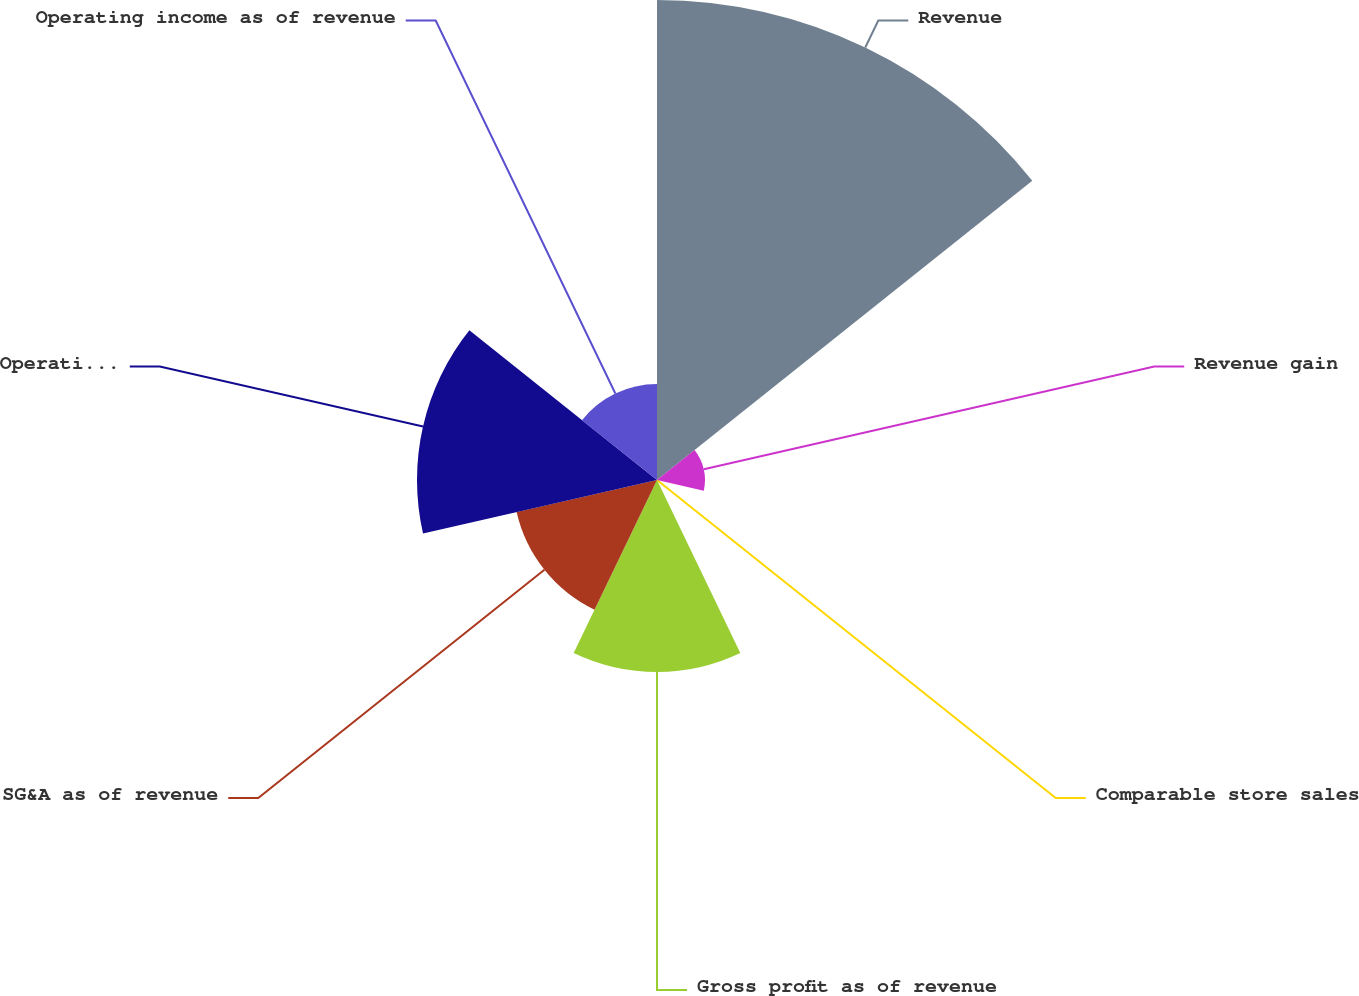Convert chart to OTSL. <chart><loc_0><loc_0><loc_500><loc_500><pie_chart><fcel>Revenue<fcel>Revenue gain<fcel>Comparable store sales<fcel>Gross profit as of revenue<fcel>SG&A as of revenue<fcel>Operating income<fcel>Operating income as of revenue<nl><fcel>40.0%<fcel>4.0%<fcel>0.0%<fcel>16.0%<fcel>12.0%<fcel>20.0%<fcel>8.0%<nl></chart> 